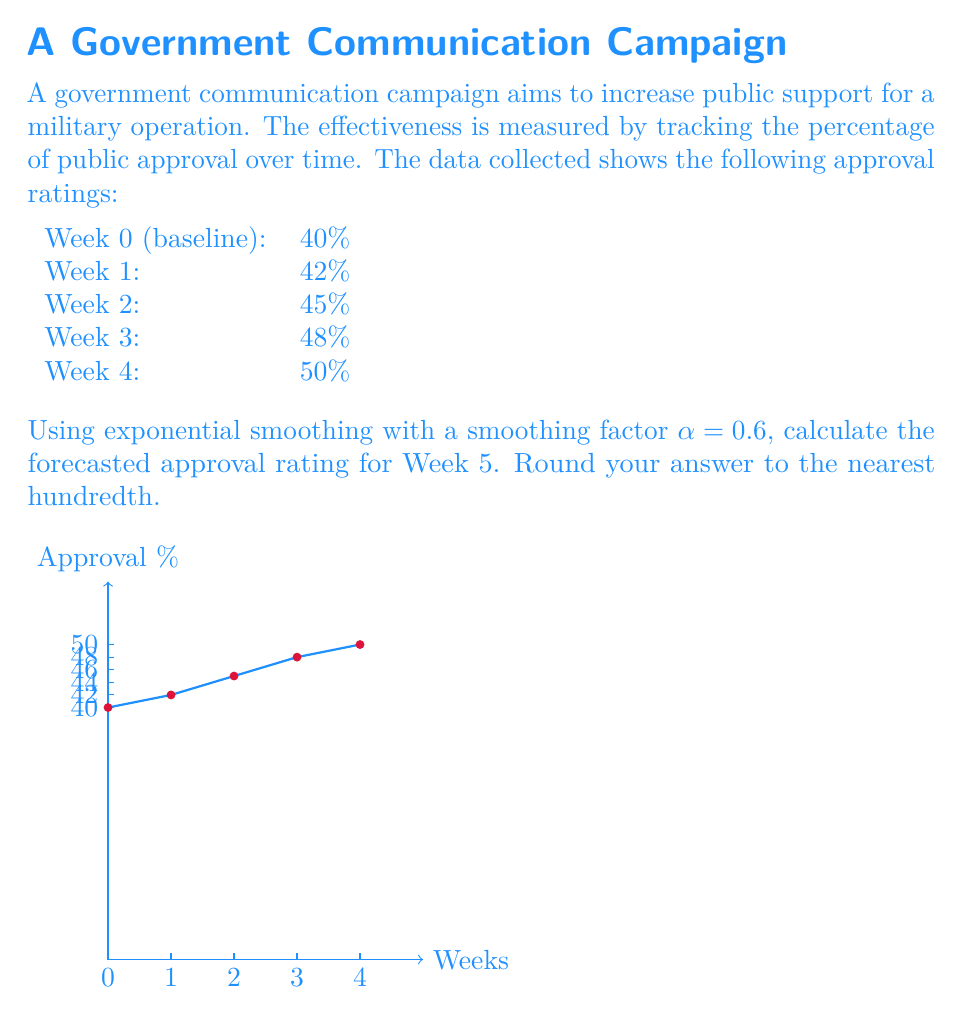Teach me how to tackle this problem. To solve this problem, we'll use the exponential smoothing formula:

$$F_{t+1} = \alpha Y_t + (1-\alpha)F_t$$

Where:
$F_{t+1}$ is the forecast for the next period
$\alpha$ is the smoothing factor (0.6 in this case)
$Y_t$ is the actual value at time t
$F_t$ is the forecast for the current period

Let's calculate step by step:

1) For Week 1:
   $F_1 = \alpha Y_0 + (1-\alpha)F_0 = 0.6(40) + 0.4(40) = 40$

2) For Week 2:
   $F_2 = 0.6(42) + 0.4(40) = 41.2$

3) For Week 3:
   $F_3 = 0.6(45) + 0.4(41.2) = 43.48$

4) For Week 4:
   $F_4 = 0.6(48) + 0.4(43.48) = 46.192$

5) For Week 5 (our target):
   $F_5 = 0.6(50) + 0.4(46.192) = 48.4768$

Rounding to the nearest hundredth, we get 48.48%.
Answer: 48.48% 